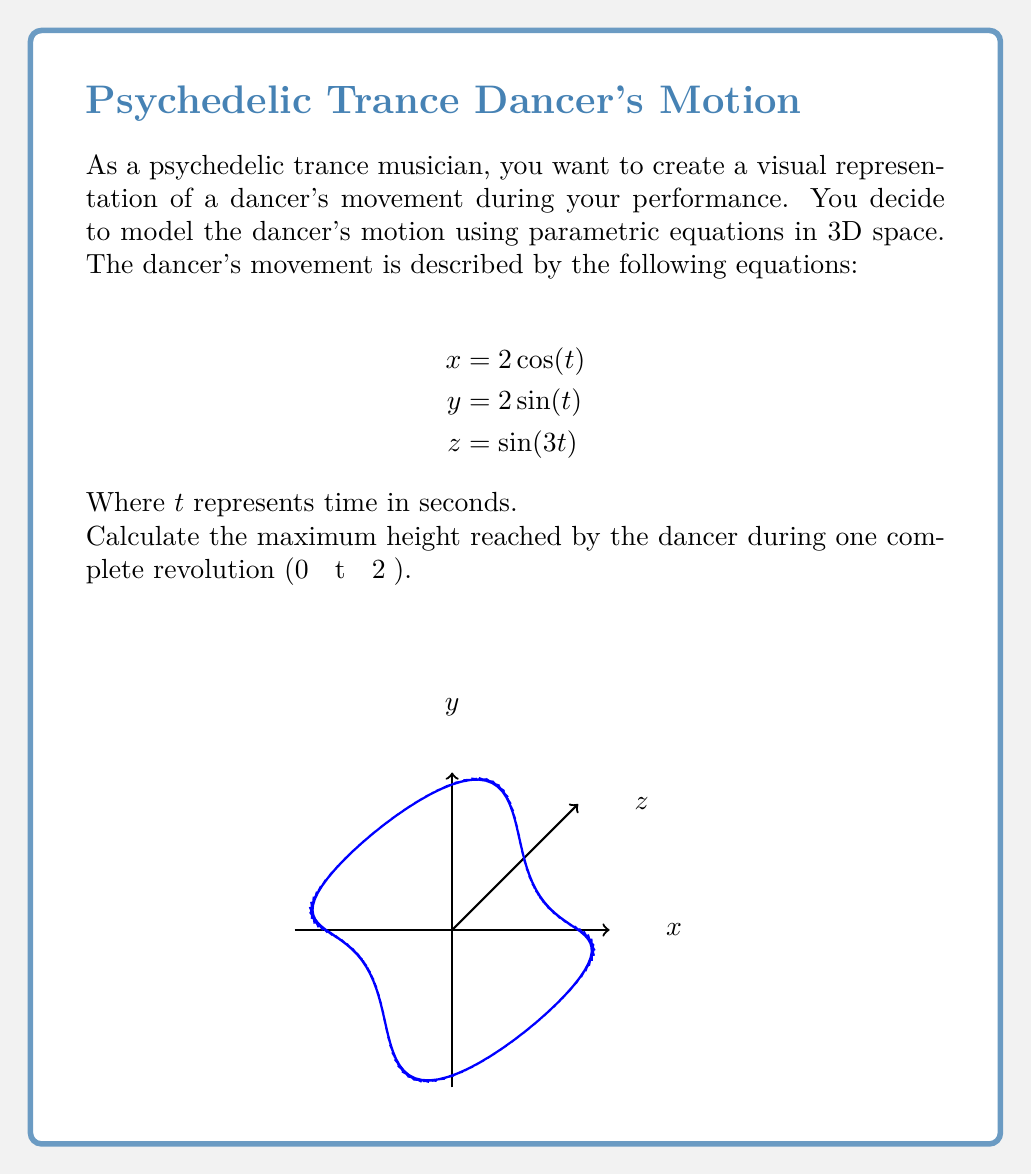Provide a solution to this math problem. Let's approach this step-by-step:

1) The dancer's height is represented by the z-coordinate in the parametric equations.

2) The z-coordinate is given by the equation: $z = \sin(3t)$

3) To find the maximum height, we need to find the maximum value of $\sin(3t)$ over the interval $0 \leq t \leq 2\pi$.

4) We know that the maximum value of sine function is 1, which occurs when its argument is $\frac{\pi}{2} + 2\pi n$, where n is any integer.

5) So, we need to solve:
   $3t = \frac{\pi}{2} + 2\pi n$

6) Solving for t:
   $t = \frac{\pi}{6} + \frac{2\pi n}{3}$

7) We need to find a value of n that gives us a t in the range $0 \leq t \leq 2\pi$.

8) When n = 0, $t = \frac{\pi}{6} \approx 0.52$, which is within our range.

9) Therefore, the maximum value of z occurs at $t = \frac{\pi}{6}$.

10) The maximum height is:
    $z_{max} = \sin(3 \cdot \frac{\pi}{6}) = \sin(\frac{\pi}{2}) = 1$

Thus, the maximum height reached by the dancer is 1 unit.
Answer: 1 unit 